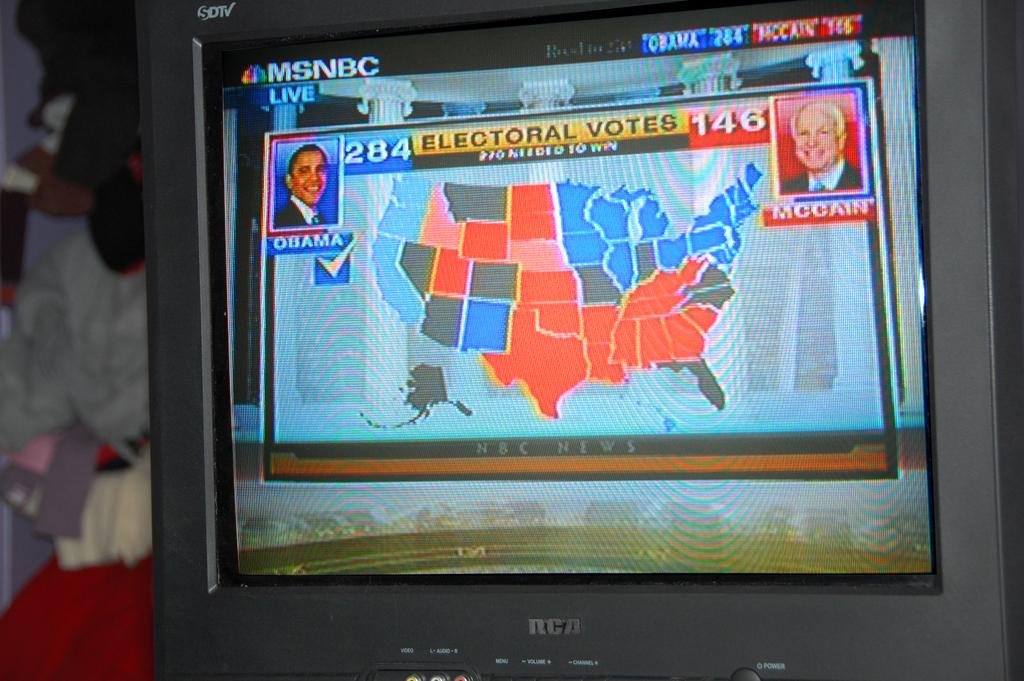What is the main object in the image? There is a screen in the image. What can be seen on the screen? People are visible on the screen. Can you describe the background of the image? The background of the image is blurry. What type of oatmeal is being served as an example in the image? There is no oatmeal or example present in the image; it only features a screen with people visible. 